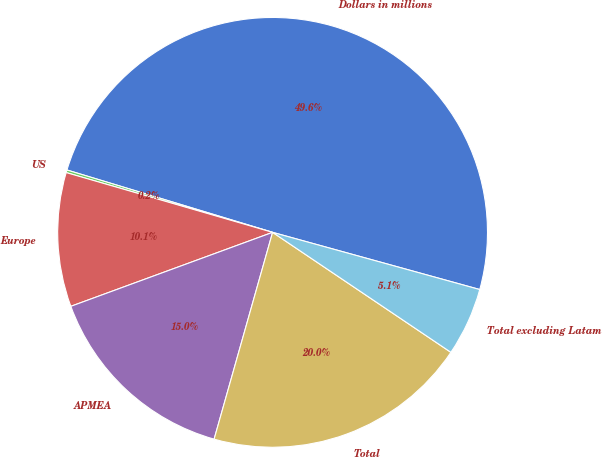Convert chart to OTSL. <chart><loc_0><loc_0><loc_500><loc_500><pie_chart><fcel>Dollars in millions<fcel>US<fcel>Europe<fcel>APMEA<fcel>Total<fcel>Total excluding Latam<nl><fcel>49.6%<fcel>0.2%<fcel>10.08%<fcel>15.02%<fcel>19.96%<fcel>5.14%<nl></chart> 